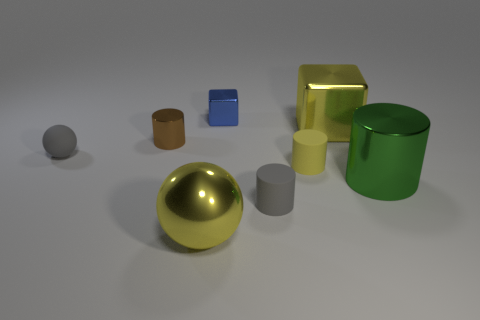Subtract all small yellow matte cylinders. How many cylinders are left? 3 Subtract 1 cubes. How many cubes are left? 1 Add 1 small gray rubber balls. How many objects exist? 9 Subtract all blocks. How many objects are left? 6 Subtract all yellow balls. How many gray blocks are left? 0 Subtract all small blue matte cylinders. Subtract all metallic cubes. How many objects are left? 6 Add 3 tiny gray rubber objects. How many tiny gray rubber objects are left? 5 Add 8 small metal cylinders. How many small metal cylinders exist? 9 Subtract all brown cylinders. How many cylinders are left? 3 Subtract 0 brown spheres. How many objects are left? 8 